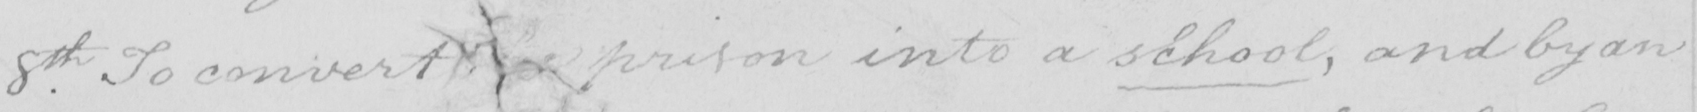Please provide the text content of this handwritten line. 8th . To convert the prison into a school , and by an 